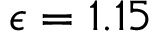Convert formula to latex. <formula><loc_0><loc_0><loc_500><loc_500>\epsilon = 1 . 1 5</formula> 